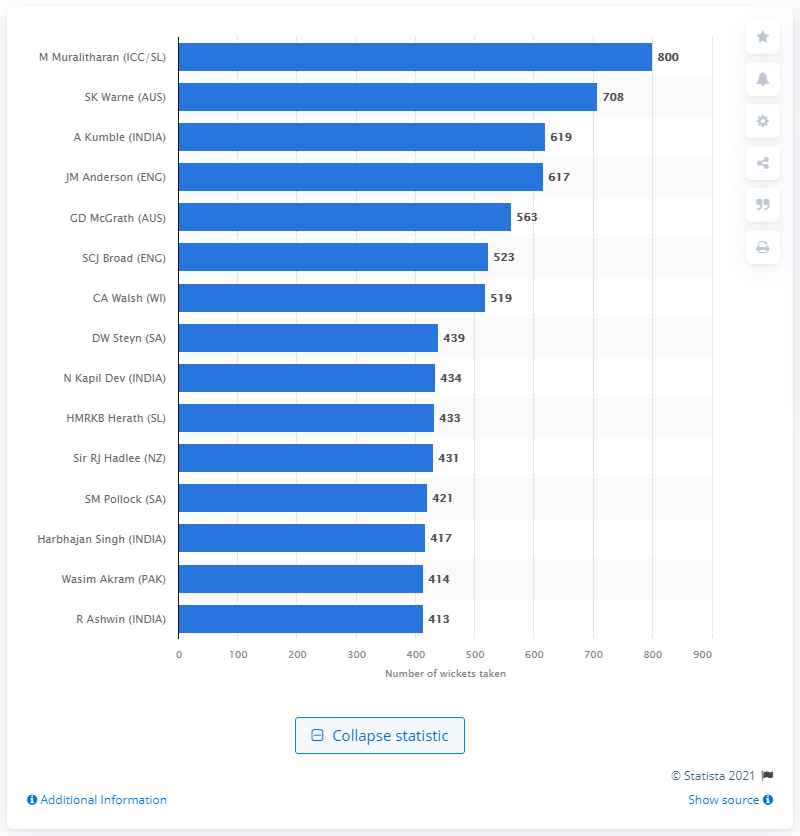List a handful of essential elements in this visual. Muttiah Muralitharan took 800 wickets in his test career, a remarkable achievement. 